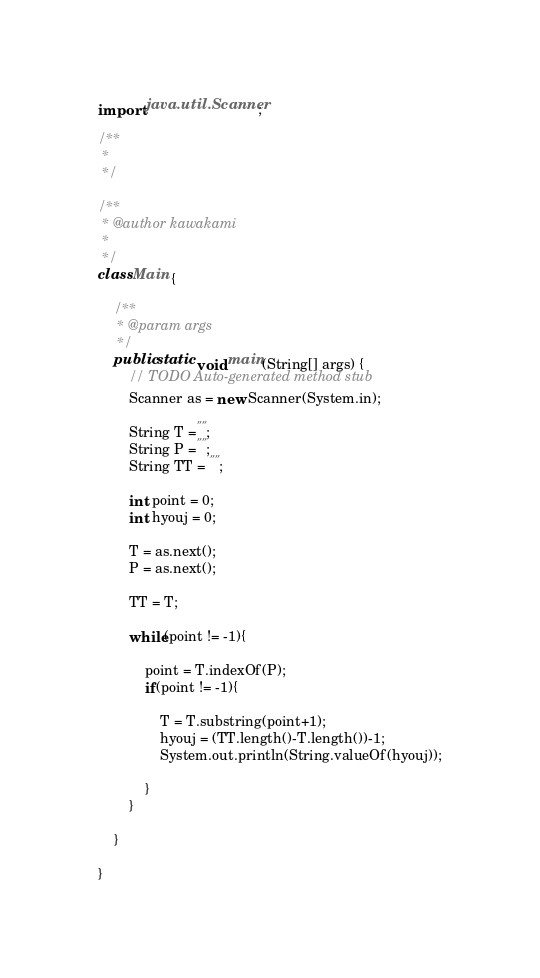Convert code to text. <code><loc_0><loc_0><loc_500><loc_500><_Java_>import java.util.Scanner;
  
/**
 * 
 */
  
/**
 * @author kawakami
 *
 */
class Main {
  
    /**
     * @param args
     */
    public static void main(String[] args) {
        // TODO Auto-generated method stub
        Scanner as = new Scanner(System.in);
          
        String T ="";
        String P ="";
        String TT = "";
          
        int point = 0;
        int hyouj = 0;
          
        T = as.next();
        P = as.next();
          
        TT = T;
          
        while(point != -1){
              
            point = T.indexOf(P);
            if(point != -1){
              
                T = T.substring(point+1);
                hyouj = (TT.length()-T.length())-1;
                System.out.println(String.valueOf(hyouj));
                  
            }
        }
  
    }
  
}</code> 